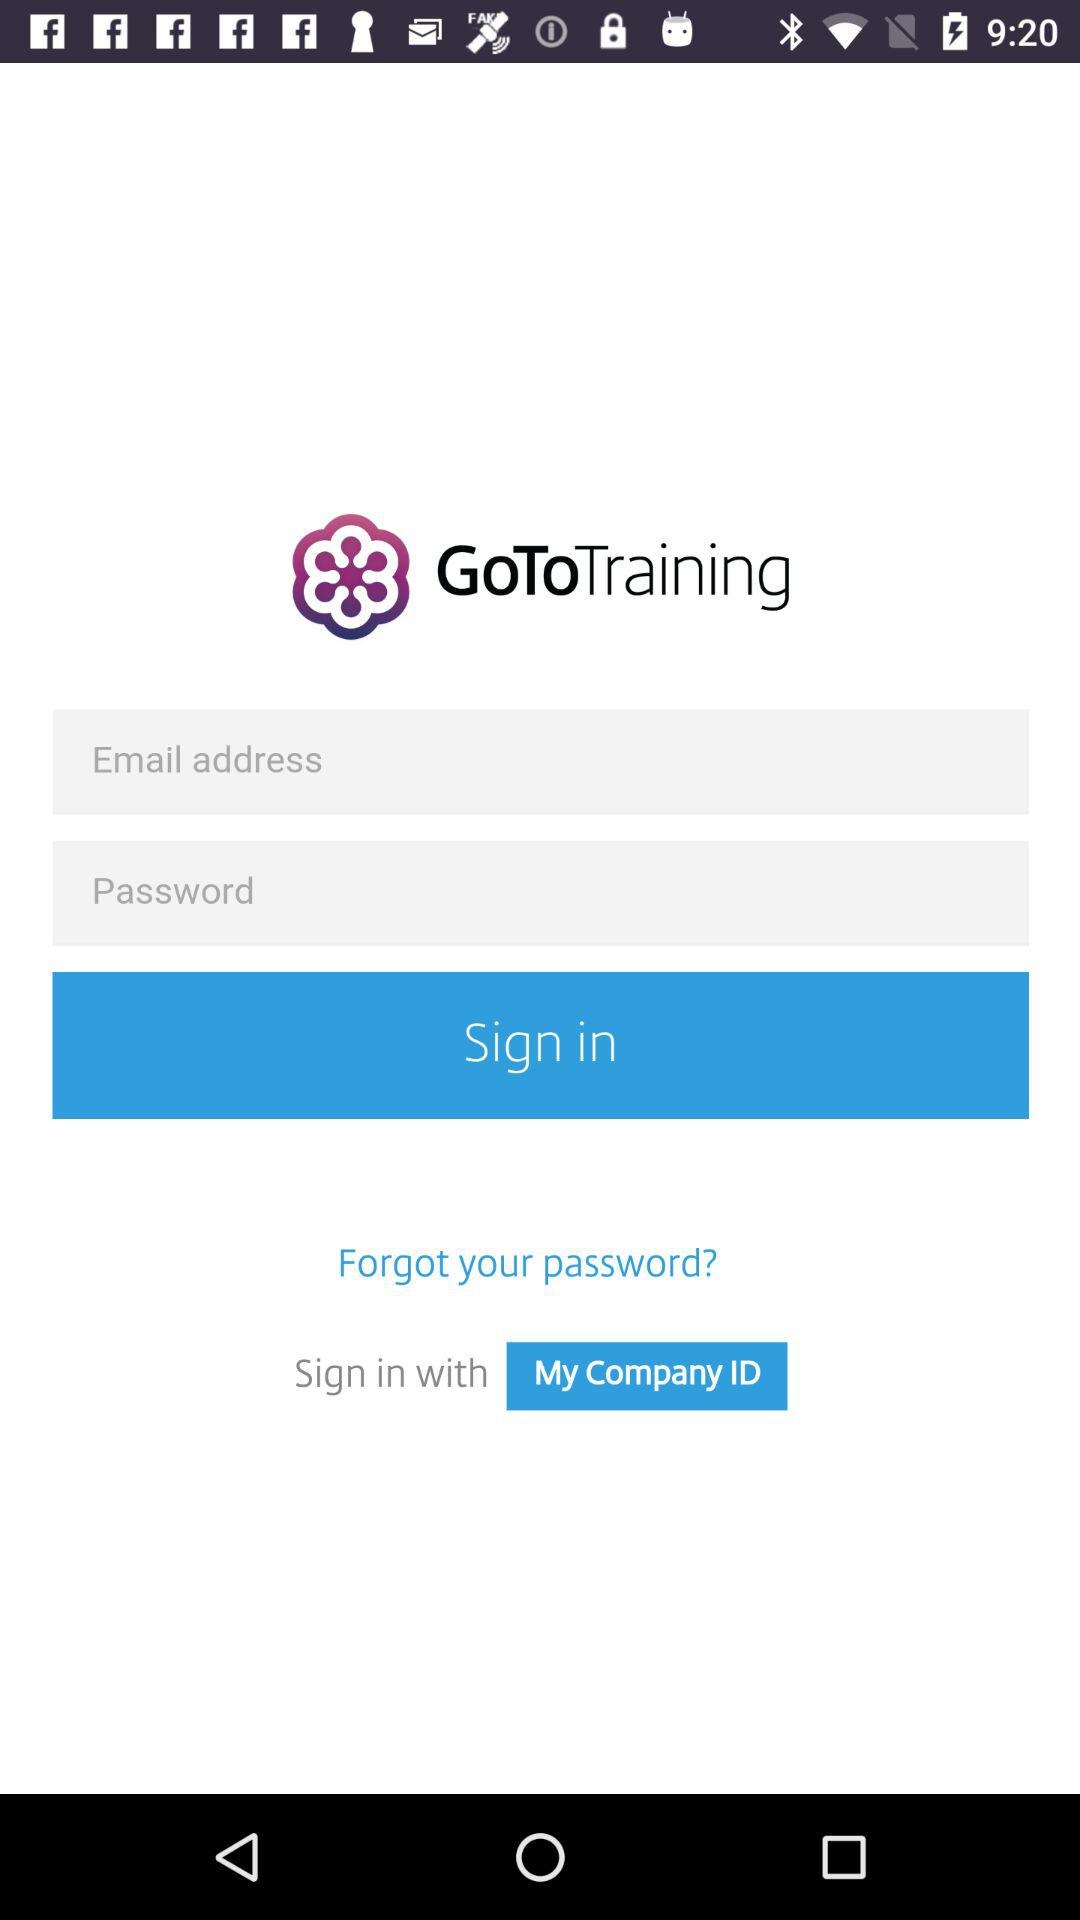What are the requirements to sign in? The requirements to sign in are an email address and a password. 